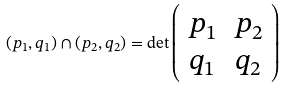<formula> <loc_0><loc_0><loc_500><loc_500>( p _ { 1 } , q _ { 1 } ) \cap ( p _ { 2 } , q _ { 2 } ) = \det \left ( \begin{array} { c c } p _ { 1 } & p _ { 2 } \\ q _ { 1 } & q _ { 2 } \end{array} \right )</formula> 